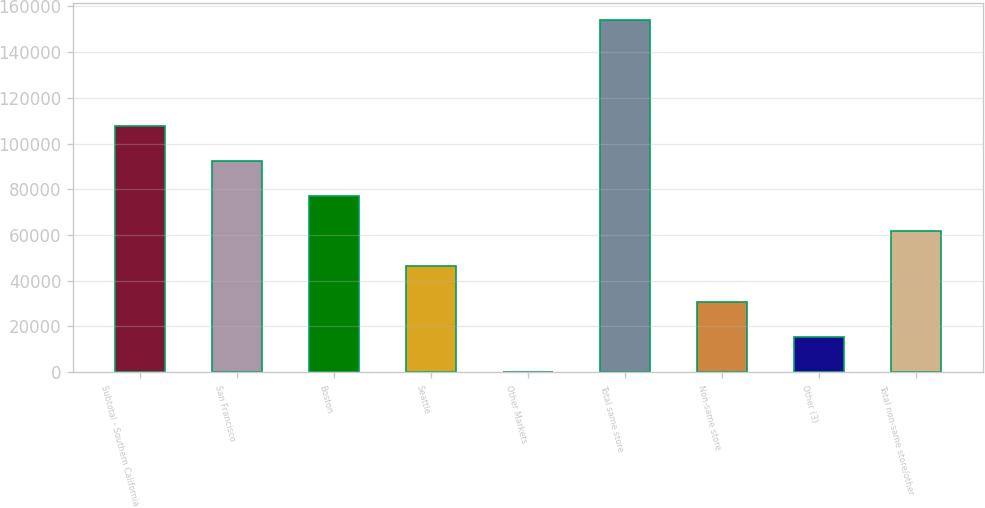<chart> <loc_0><loc_0><loc_500><loc_500><bar_chart><fcel>Subtotal - Southern California<fcel>San Francisco<fcel>Boston<fcel>Seattle<fcel>Other Markets<fcel>Total same store<fcel>Non-same store<fcel>Other (3)<fcel>Total non-same store/other<nl><fcel>107846<fcel>92449<fcel>77052<fcel>46258<fcel>67<fcel>154037<fcel>30861<fcel>15464<fcel>61655<nl></chart> 